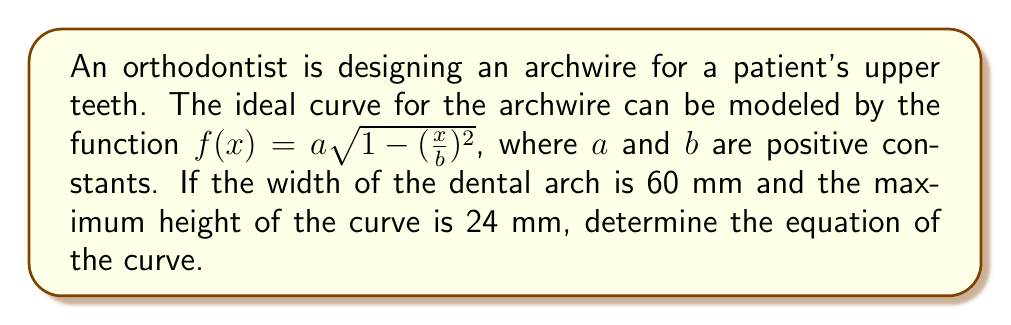Give your solution to this math problem. To solve this problem, we'll follow these steps:

1) The function $f(x) = a\sqrt{1-(\frac{x}{b})^2}$ is the equation of an ellipse, where:
   - $a$ is the vertical semi-axis (half of the height)
   - $b$ is the horizontal semi-axis (half of the width)

2) Given information:
   - Width of dental arch = 60 mm, so $b = 30$ mm
   - Maximum height of curve = 24 mm, so $a = 24$ mm

3) Substituting these values into the general equation:

   $$f(x) = 24\sqrt{1-(\frac{x}{30})^2}$$

4) To verify:
   - When $x = 0$, $f(0) = 24\sqrt{1-0^2} = 24$ mm (maximum height)
   - When $x = \pm30$, $f(\pm30) = 24\sqrt{1-1} = 0$ (ends of the arch)

5) Therefore, the equation $f(x) = 24\sqrt{1-(\frac{x}{30})^2}$ correctly models the optimal curve for the archwire.
Answer: $f(x) = 24\sqrt{1-(\frac{x}{30})^2}$ 